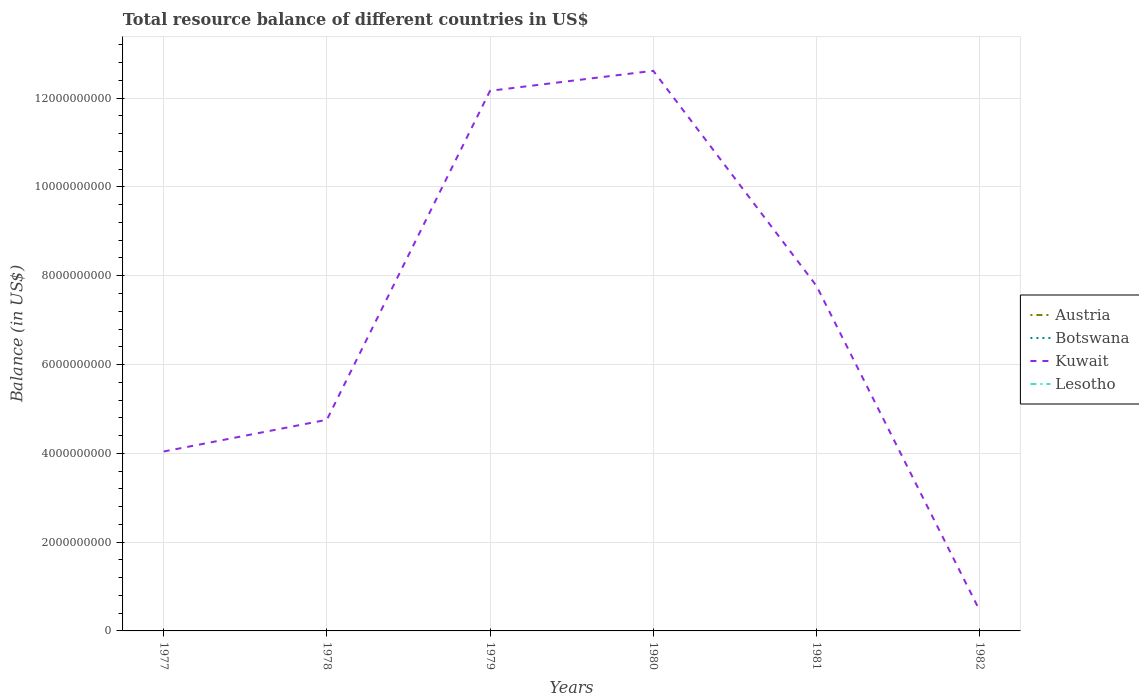How many different coloured lines are there?
Provide a succinct answer. 1. Across all years, what is the maximum total resource balance in Kuwait?
Offer a terse response. 4.62e+08. What is the total total resource balance in Kuwait in the graph?
Your answer should be compact. 3.58e+09. Is the total resource balance in Kuwait strictly greater than the total resource balance in Botswana over the years?
Your answer should be very brief. No. How many lines are there?
Your answer should be compact. 1. How many years are there in the graph?
Offer a very short reply. 6. What is the difference between two consecutive major ticks on the Y-axis?
Give a very brief answer. 2.00e+09. Are the values on the major ticks of Y-axis written in scientific E-notation?
Your answer should be compact. No. Does the graph contain grids?
Your answer should be compact. Yes. How many legend labels are there?
Provide a short and direct response. 4. What is the title of the graph?
Provide a succinct answer. Total resource balance of different countries in US$. Does "Singapore" appear as one of the legend labels in the graph?
Offer a terse response. No. What is the label or title of the Y-axis?
Give a very brief answer. Balance (in US$). What is the Balance (in US$) of Austria in 1977?
Your response must be concise. 0. What is the Balance (in US$) of Kuwait in 1977?
Ensure brevity in your answer.  4.04e+09. What is the Balance (in US$) of Lesotho in 1977?
Make the answer very short. 0. What is the Balance (in US$) in Austria in 1978?
Your answer should be very brief. 0. What is the Balance (in US$) in Botswana in 1978?
Make the answer very short. 0. What is the Balance (in US$) of Kuwait in 1978?
Make the answer very short. 4.76e+09. What is the Balance (in US$) in Austria in 1979?
Keep it short and to the point. 0. What is the Balance (in US$) in Botswana in 1979?
Make the answer very short. 0. What is the Balance (in US$) of Kuwait in 1979?
Provide a succinct answer. 1.22e+1. What is the Balance (in US$) in Botswana in 1980?
Ensure brevity in your answer.  0. What is the Balance (in US$) of Kuwait in 1980?
Your answer should be very brief. 1.26e+1. What is the Balance (in US$) of Lesotho in 1980?
Provide a short and direct response. 0. What is the Balance (in US$) in Botswana in 1981?
Give a very brief answer. 0. What is the Balance (in US$) of Kuwait in 1981?
Provide a succinct answer. 7.77e+09. What is the Balance (in US$) of Lesotho in 1981?
Make the answer very short. 0. What is the Balance (in US$) in Austria in 1982?
Ensure brevity in your answer.  0. What is the Balance (in US$) of Botswana in 1982?
Offer a terse response. 0. What is the Balance (in US$) of Kuwait in 1982?
Make the answer very short. 4.62e+08. Across all years, what is the maximum Balance (in US$) in Kuwait?
Your answer should be compact. 1.26e+1. Across all years, what is the minimum Balance (in US$) in Kuwait?
Provide a succinct answer. 4.62e+08. What is the total Balance (in US$) of Botswana in the graph?
Offer a very short reply. 0. What is the total Balance (in US$) in Kuwait in the graph?
Provide a succinct answer. 4.18e+1. What is the total Balance (in US$) in Lesotho in the graph?
Give a very brief answer. 0. What is the difference between the Balance (in US$) in Kuwait in 1977 and that in 1978?
Give a very brief answer. -7.14e+08. What is the difference between the Balance (in US$) of Kuwait in 1977 and that in 1979?
Give a very brief answer. -8.12e+09. What is the difference between the Balance (in US$) of Kuwait in 1977 and that in 1980?
Offer a terse response. -8.57e+09. What is the difference between the Balance (in US$) in Kuwait in 1977 and that in 1981?
Ensure brevity in your answer.  -3.73e+09. What is the difference between the Balance (in US$) in Kuwait in 1977 and that in 1982?
Your answer should be very brief. 3.58e+09. What is the difference between the Balance (in US$) of Kuwait in 1978 and that in 1979?
Offer a very short reply. -7.41e+09. What is the difference between the Balance (in US$) in Kuwait in 1978 and that in 1980?
Provide a succinct answer. -7.86e+09. What is the difference between the Balance (in US$) in Kuwait in 1978 and that in 1981?
Offer a very short reply. -3.02e+09. What is the difference between the Balance (in US$) in Kuwait in 1978 and that in 1982?
Your answer should be very brief. 4.29e+09. What is the difference between the Balance (in US$) of Kuwait in 1979 and that in 1980?
Offer a terse response. -4.51e+08. What is the difference between the Balance (in US$) of Kuwait in 1979 and that in 1981?
Give a very brief answer. 4.39e+09. What is the difference between the Balance (in US$) in Kuwait in 1979 and that in 1982?
Offer a terse response. 1.17e+1. What is the difference between the Balance (in US$) in Kuwait in 1980 and that in 1981?
Ensure brevity in your answer.  4.84e+09. What is the difference between the Balance (in US$) of Kuwait in 1980 and that in 1982?
Ensure brevity in your answer.  1.22e+1. What is the difference between the Balance (in US$) in Kuwait in 1981 and that in 1982?
Ensure brevity in your answer.  7.31e+09. What is the average Balance (in US$) in Kuwait per year?
Provide a short and direct response. 6.97e+09. What is the ratio of the Balance (in US$) of Kuwait in 1977 to that in 1978?
Provide a short and direct response. 0.85. What is the ratio of the Balance (in US$) of Kuwait in 1977 to that in 1979?
Your response must be concise. 0.33. What is the ratio of the Balance (in US$) in Kuwait in 1977 to that in 1980?
Offer a terse response. 0.32. What is the ratio of the Balance (in US$) of Kuwait in 1977 to that in 1981?
Your answer should be compact. 0.52. What is the ratio of the Balance (in US$) of Kuwait in 1977 to that in 1982?
Offer a very short reply. 8.75. What is the ratio of the Balance (in US$) in Kuwait in 1978 to that in 1979?
Your answer should be compact. 0.39. What is the ratio of the Balance (in US$) of Kuwait in 1978 to that in 1980?
Keep it short and to the point. 0.38. What is the ratio of the Balance (in US$) in Kuwait in 1978 to that in 1981?
Offer a terse response. 0.61. What is the ratio of the Balance (in US$) in Kuwait in 1978 to that in 1982?
Give a very brief answer. 10.29. What is the ratio of the Balance (in US$) in Kuwait in 1979 to that in 1981?
Give a very brief answer. 1.56. What is the ratio of the Balance (in US$) of Kuwait in 1979 to that in 1982?
Provide a short and direct response. 26.33. What is the ratio of the Balance (in US$) in Kuwait in 1980 to that in 1981?
Ensure brevity in your answer.  1.62. What is the ratio of the Balance (in US$) in Kuwait in 1980 to that in 1982?
Provide a short and direct response. 27.31. What is the ratio of the Balance (in US$) of Kuwait in 1981 to that in 1982?
Your answer should be very brief. 16.83. What is the difference between the highest and the second highest Balance (in US$) of Kuwait?
Your answer should be compact. 4.51e+08. What is the difference between the highest and the lowest Balance (in US$) of Kuwait?
Offer a terse response. 1.22e+1. 